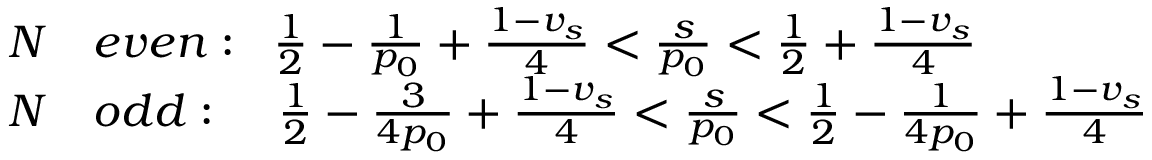<formula> <loc_0><loc_0><loc_500><loc_500>\begin{array} { r l } { N } & { { e v e n \colon \, \frac { 1 } { 2 } - \frac { 1 } { p _ { 0 } } + \frac { 1 - v _ { s } } { 4 } < \frac { s } { p _ { 0 } } < \frac { 1 } { 2 } + \frac { 1 - v _ { s } } { 4 } } } \\ { N } & { { o d d \colon \, \frac { 1 } { 2 } - \frac { 3 } { 4 p _ { 0 } } + \frac { 1 - v _ { s } } { 4 } < \frac { s } { p _ { 0 } } < \frac { 1 } { 2 } - \frac { 1 } { 4 p _ { 0 } } + \frac { 1 - v _ { s } } { 4 } } } \end{array}</formula> 